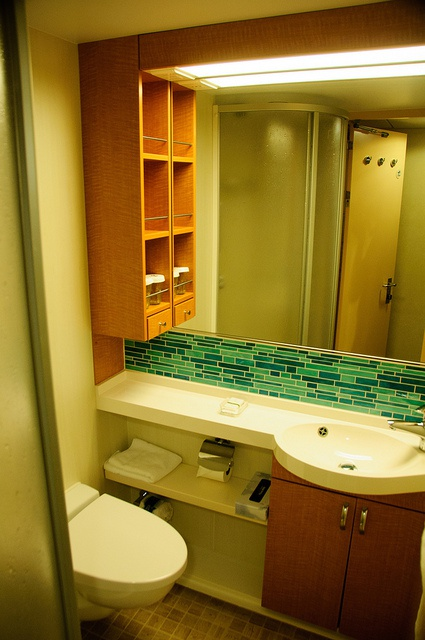Describe the objects in this image and their specific colors. I can see sink in black, khaki, lightyellow, tan, and olive tones, toilet in black, khaki, and olive tones, cup in black, olive, maroon, khaki, and lightyellow tones, and cup in black, olive, maroon, and orange tones in this image. 